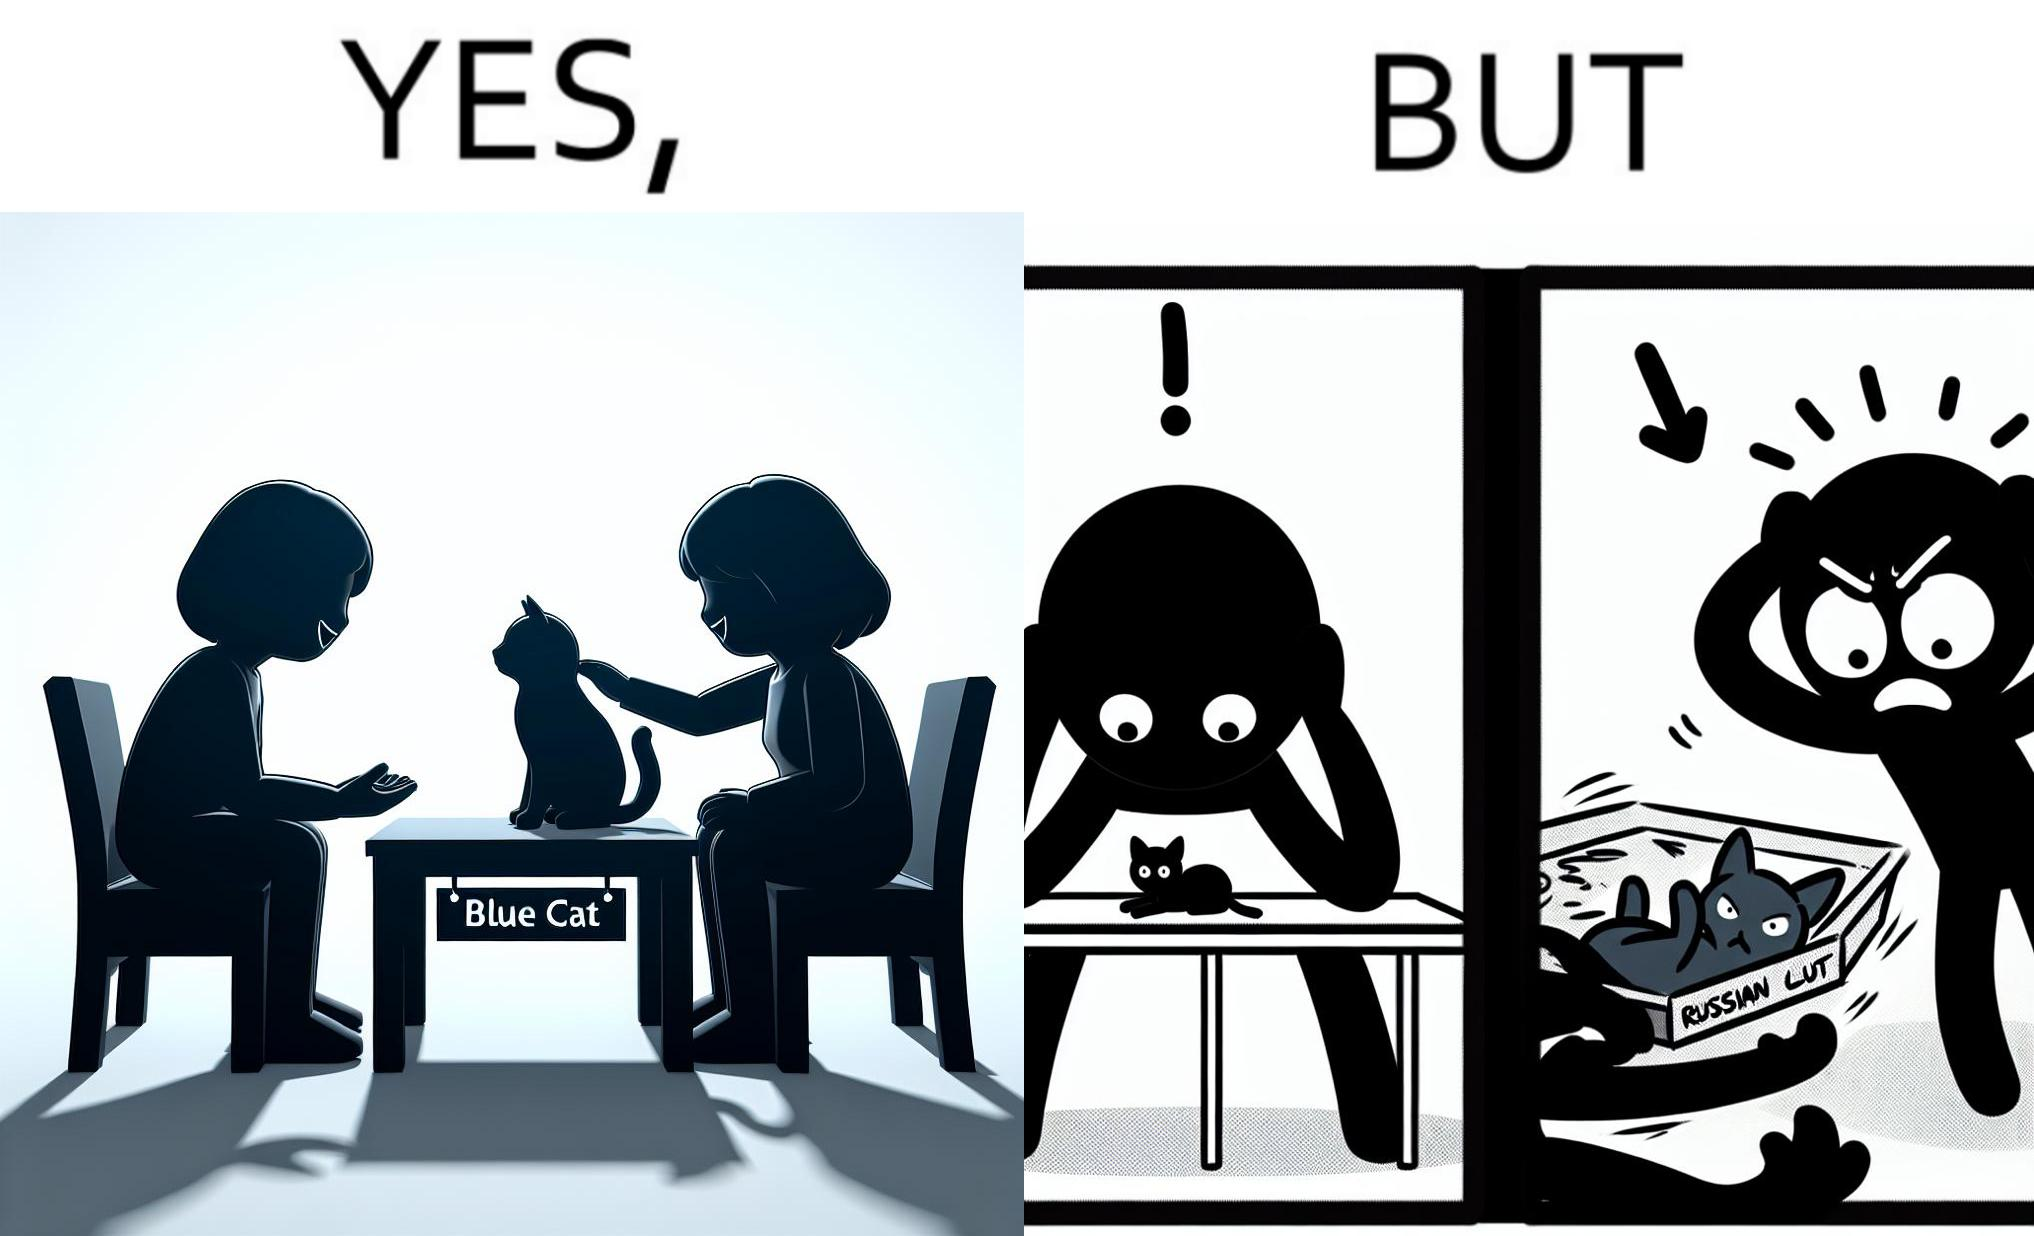What is shown in the left half versus the right half of this image? In the left part of the image: two happy people, where one of them is petting a cat sitting on a table, with a label "Blue Cat" written on the tabel. In the right part of the image: a worried person with hands on her head looking at a table with the label "Russian Blue Cat", while another angry person seems to be throwing away a cat. 